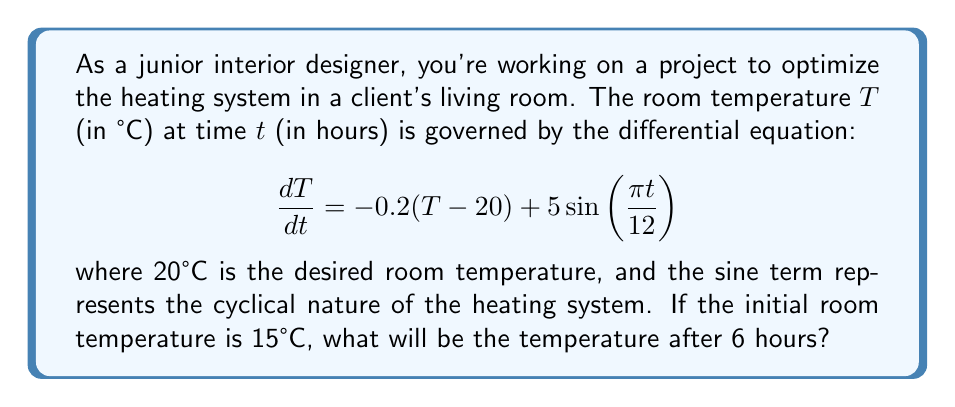Can you solve this math problem? To solve this problem, we need to use the method for solving first-order linear differential equations.

1) First, let's identify the parts of our differential equation:
   $$\frac{dT}{dt} + 0.2T = 4 + 5\sin(\frac{\pi t}{12})$$

2) The integrating factor is $e^{\int 0.2 dt} = e^{0.2t}$

3) Multiply both sides by the integrating factor:
   $$e^{0.2t}\frac{dT}{dt} + 0.2Te^{0.2t} = 4e^{0.2t} + 5e^{0.2t}\sin(\frac{\pi t}{12})$$

4) The left side is now the derivative of $Te^{0.2t}$:
   $$\frac{d}{dt}(Te^{0.2t}) = 4e^{0.2t} + 5e^{0.2t}\sin(\frac{\pi t}{12})$$

5) Integrate both sides:
   $$Te^{0.2t} = 20e^{0.2t} - \frac{60}{\pi}\cos(\frac{\pi t}{12})e^{0.2t} + C$$

6) Solve for T:
   $$T = 20 - \frac{60}{\pi}\cos(\frac{\pi t}{12}) + Ce^{-0.2t}$$

7) Use the initial condition T(0) = 15 to find C:
   $$15 = 20 - \frac{60}{\pi} + C$$
   $$C = 15 - 20 + \frac{60}{\pi} = -5 + \frac{60}{\pi}$$

8) Our final solution is:
   $$T = 20 - \frac{60}{\pi}\cos(\frac{\pi t}{12}) + (-5 + \frac{60}{\pi})e^{-0.2t}$$

9) To find the temperature after 6 hours, substitute t = 6:
   $$T(6) = 20 - \frac{60}{\pi}\cos(\frac{\pi 6}{12}) + (-5 + \frac{60}{\pi})e^{-0.2(6)}$$
Answer: The temperature after 6 hours is approximately 21.57°C. 